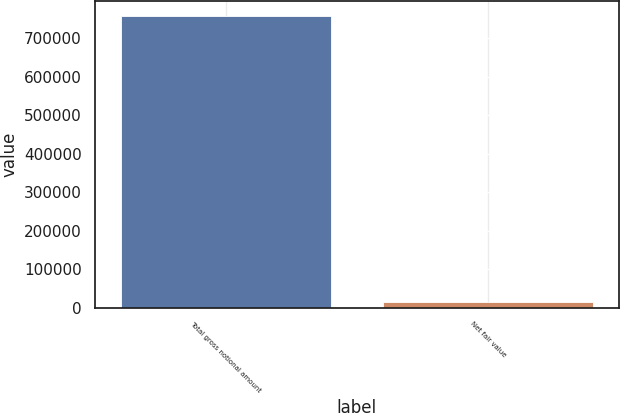Convert chart. <chart><loc_0><loc_0><loc_500><loc_500><bar_chart><fcel>Total gross notional amount<fcel>Net fair value<nl><fcel>758246<fcel>15358<nl></chart> 